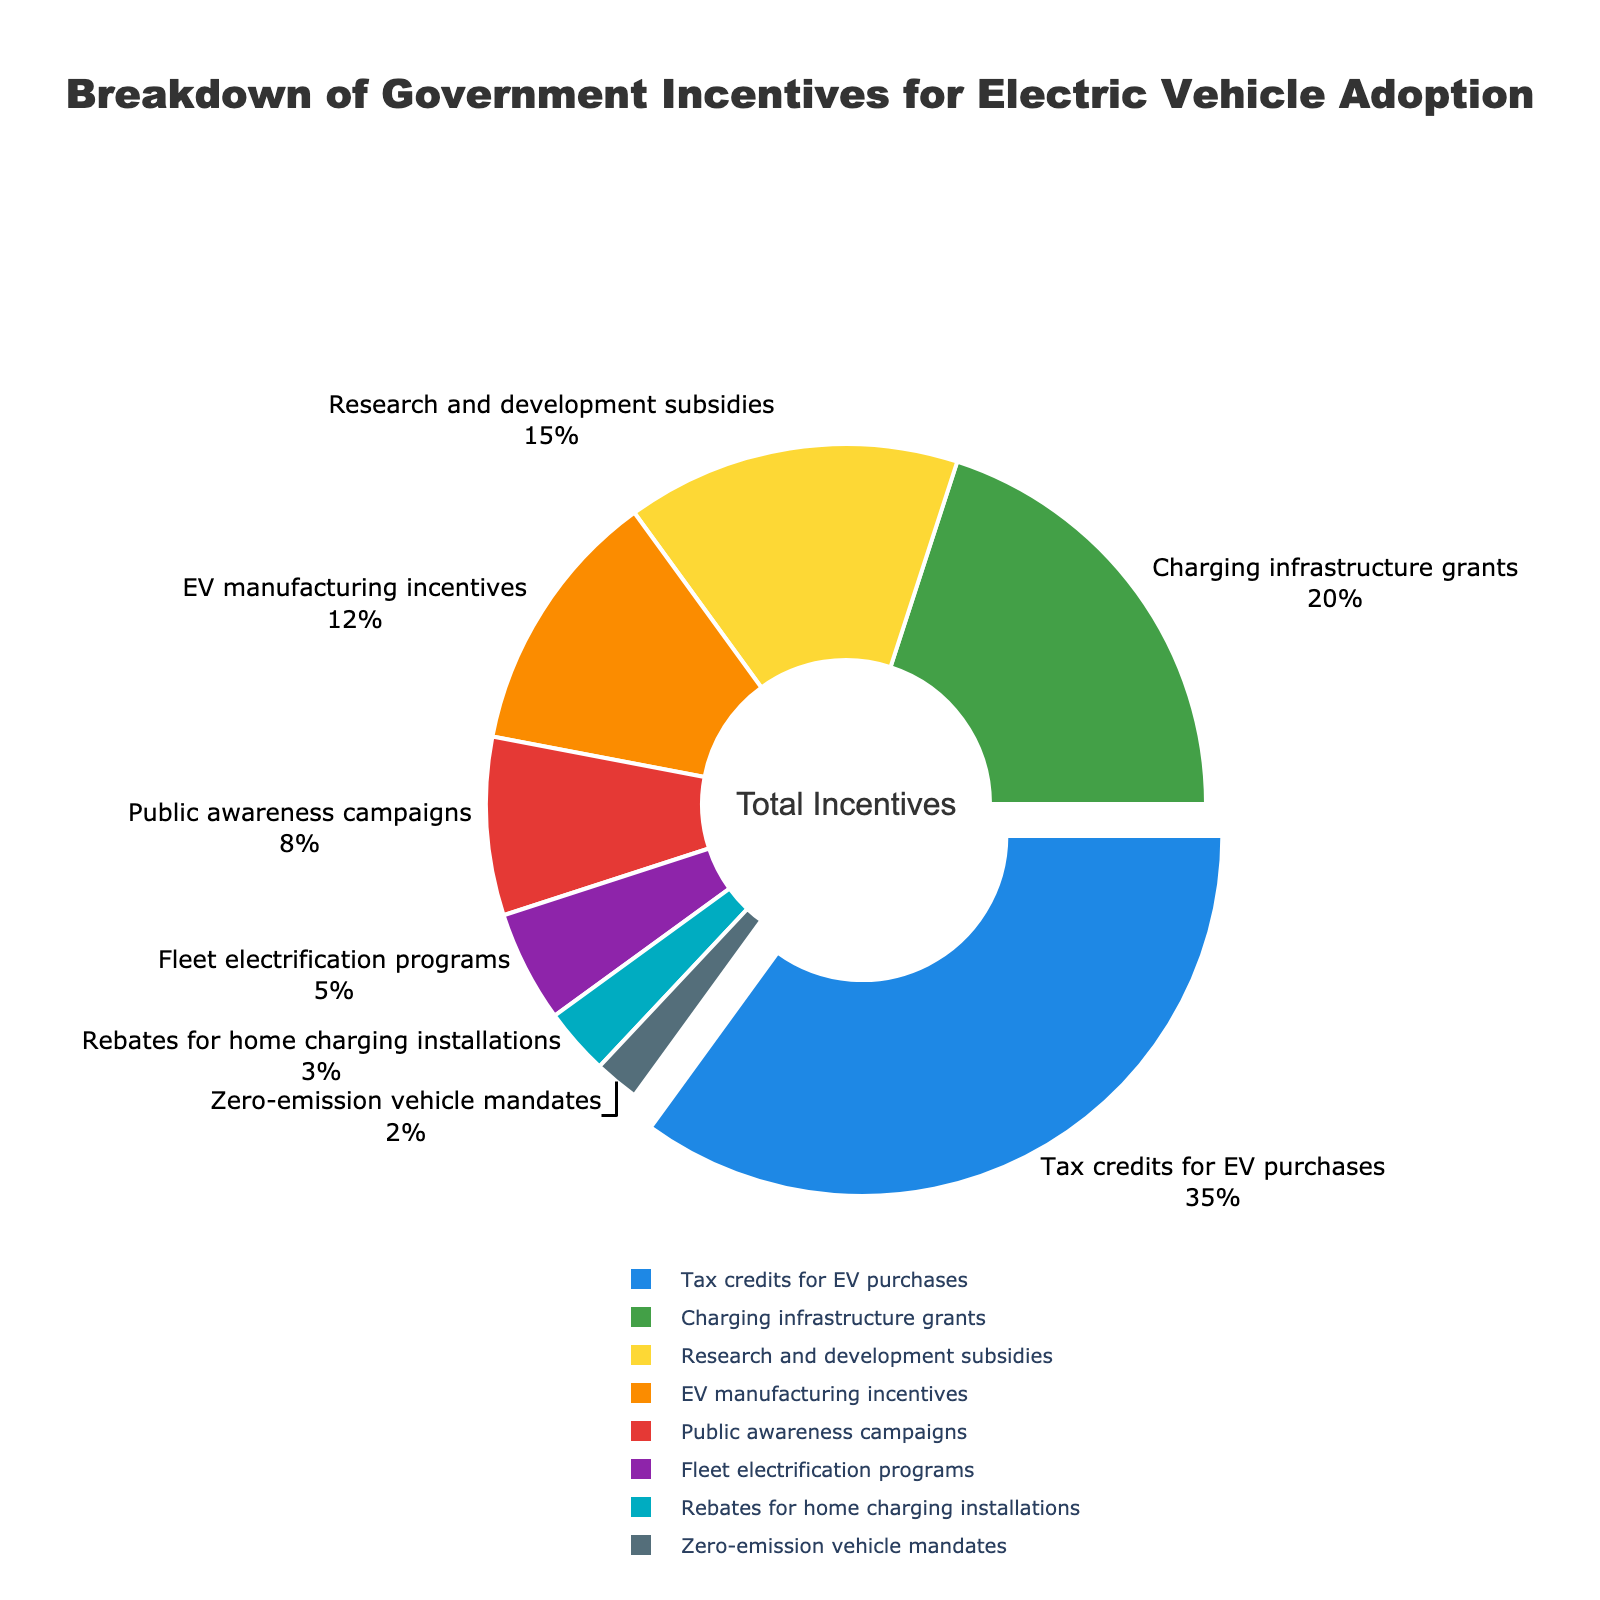What's the largest category of government incentives for electric vehicle adoption? The largest category can be found by identifying the slice with the highest percentage. "Tax credits for EV purchases" occupies the largest slice at 35%.
Answer: Tax credits for EV purchases How do the incentives for "Public awareness campaigns" compare to those for "Research and development subsidies"? To compare these incentives, look at their respective percentages. "Public awareness campaigns" have 8%, while "Research and development subsidies" have 15%. 8% is less than 15%.
Answer: Less than Which category of incentives is represented by the smallest slice? The smallest slice corresponds to the "Zero-emission vehicle mandates" category, which has a 2% share.
Answer: Zero-emission vehicle mandates What is the combined percentage of incentives for "Charging infrastructure grants" and "EV manufacturing incentives"? Adding the percentages for these two categories: 20% (Charging infrastructure grants) + 12% (EV manufacturing incentives) = 32%.
Answer: 32% How does the representation of "Fleet electrification programs" differ visually from "Rebates for home charging installations"? Visually, the slice for "Fleet electrification programs" at 5% is larger than that for "Rebates for home charging installations" at 3%, meaning the former occupies more space in the pie chart.
Answer: Fleet electrification programs are larger Is the percentage share of the "Charging infrastructure grants" category more than double that of "Public awareness campaigns"? To determine this, calculate twice the percentage of "Public awareness campaigns": 2 * 8% = 16%. "Charging infrastructure grants" have a 20% share, which is indeed more than 16%.
Answer: Yes What percentage is covered by the three smallest categories combined? Add the percentages of the smallest three categories: 5% (Fleet electrification programs) + 3% (Rebates for home charging installations) + 2% (Zero-emission vehicle mandates) = 10%.
Answer: 10% How many categories have a percentage share greater than or equal to 10%? By checking the categories: "Tax credits for EV purchases" (35%), "Charging infrastructure grants" (20%), "Research and development subsidies" (15%), "EV manufacturing incentives" (12%). Thus, 4 categories meet the criterion.
Answer: 4 Which category is visually highlighted (pulled out) on the pie chart, and why might that be significant? "Tax credits for EV purchases" is visually highlighted by being pulled out. This signifies its importance as it holds the largest share of incentives at 35%.
Answer: Tax credits for EV purchases 